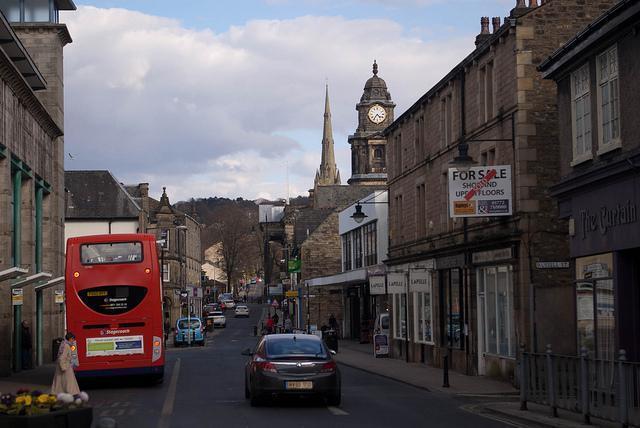How many clock faces are visible?
Give a very brief answer. 1. How many dogs are standing in boat?
Give a very brief answer. 0. 